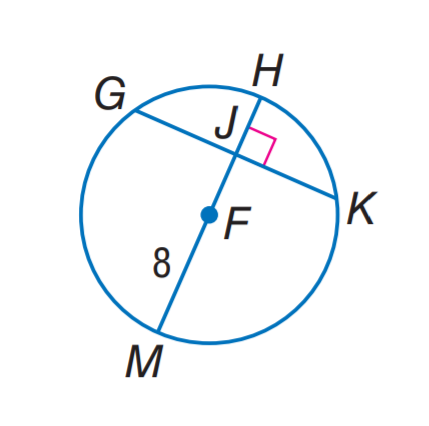Answer the mathemtical geometry problem and directly provide the correct option letter.
Question: In \odot F, G K = 14 and m \widehat G H K = 142. Find J K.
Choices: A: 7 B: 8 C: 14 D: 16 A 